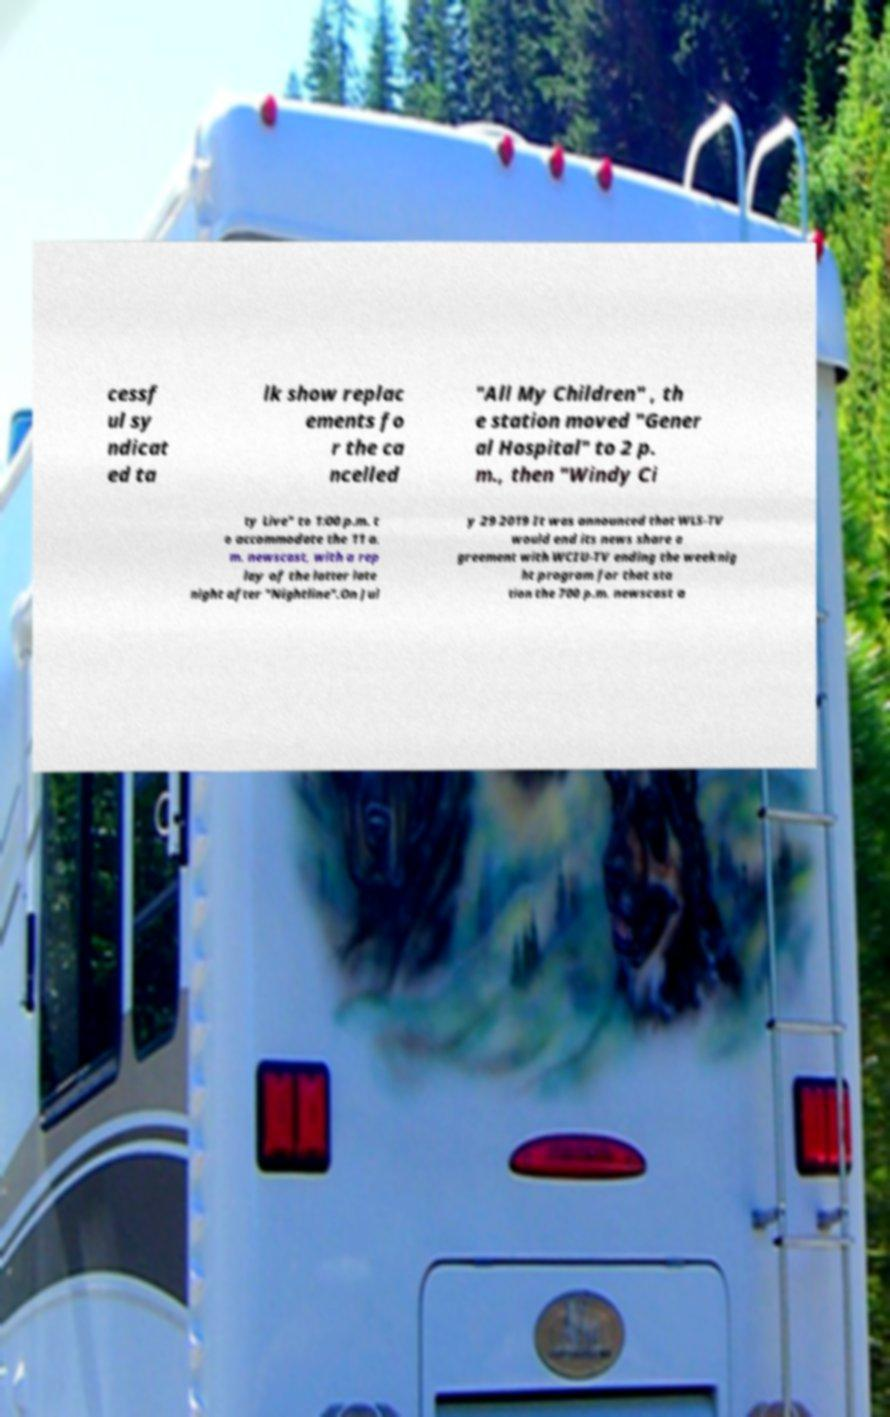Could you extract and type out the text from this image? cessf ul sy ndicat ed ta lk show replac ements fo r the ca ncelled "All My Children" , th e station moved "Gener al Hospital" to 2 p. m., then "Windy Ci ty Live" to 1:00 p.m. t o accommodate the 11 a. m. newscast, with a rep lay of the latter late night after "Nightline".On Jul y 29 2019 It was announced that WLS-TV would end its news share a greement with WCIU-TV ending the weeknig ht program for that sta tion the 700 p.m. newscast a 